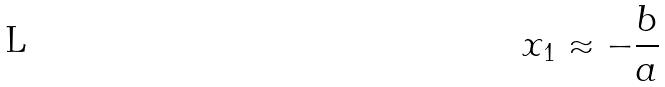<formula> <loc_0><loc_0><loc_500><loc_500>x _ { 1 } \approx - \frac { b } { a }</formula> 